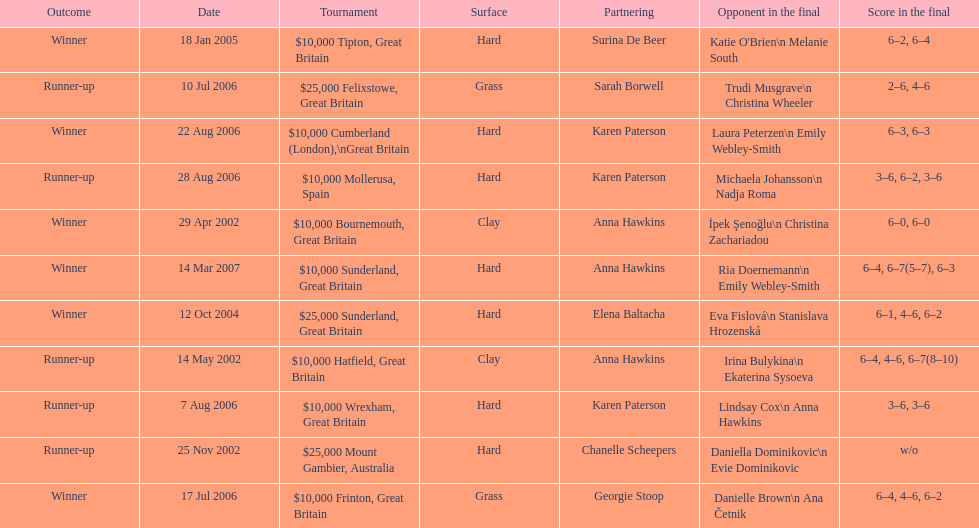How many surfaces are grass? 2. 